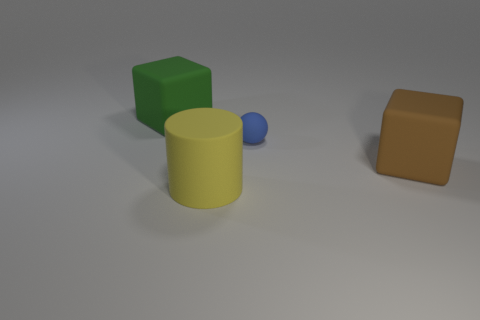Which object looks the smallest? The smallest object appears to be the blue ball. And which one would be the tallest? The tallest object in the image seems to be the yellow cylinder. 